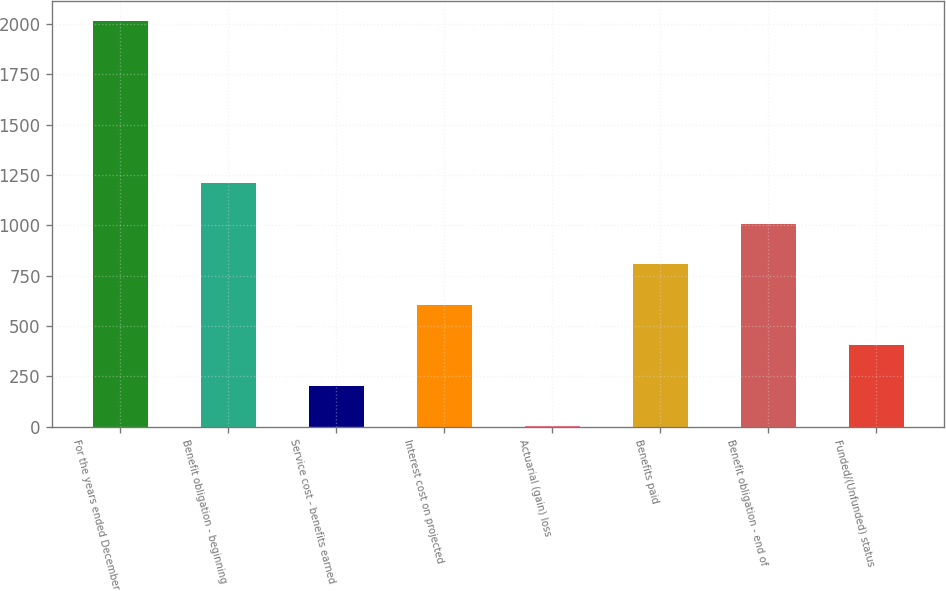Convert chart to OTSL. <chart><loc_0><loc_0><loc_500><loc_500><bar_chart><fcel>For the years ended December<fcel>Benefit obligation - beginning<fcel>Service cost - benefits earned<fcel>Interest cost on projected<fcel>Actuarial (gain) loss<fcel>Benefits paid<fcel>Benefit obligation - end of<fcel>Funded/(Unfunded) status<nl><fcel>2016<fcel>1210<fcel>202.5<fcel>605.5<fcel>1<fcel>807<fcel>1008.5<fcel>404<nl></chart> 